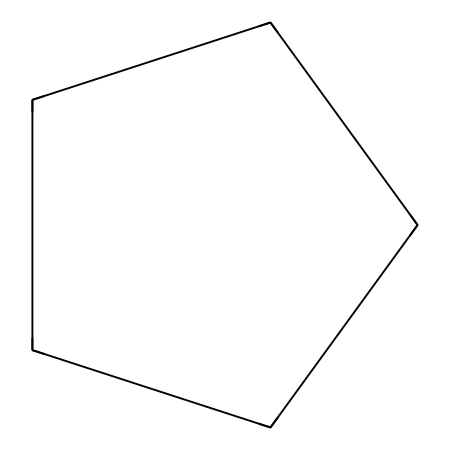What is the name of this chemical? The SMILES representation "C1CCCC1" corresponds to a cycloalkane. Specifically, it indicates a cyclic structure with five carbon atoms, which is known as cyclopentane.
Answer: cyclopentane How many carbon atoms are in cyclopentane? By analyzing the SMILES "C1CCCC1", we can see that there is a total of five 'C' symbols, indicating five carbon atoms within the structure.
Answer: five How many hydrogen atoms does cyclopentane have? Cyclopentane has the formula C5H10. Each carbon forms two hydrogens in a ring structure, resulting in 10 hydrogen atoms total.
Answer: ten Is cyclopentane a saturated or unsaturated hydrocarbon? The presence of only single bonds in cyclopentane, indicated by the absence of multiple bonds in the structure, confirms it is a saturated hydrocarbon.
Answer: saturated What type of ring structure does cyclopentane have? Cyclopentane is classified as a cycloalkane, which is characterized by its aliphatic ring structure containing carbon atoms.
Answer: aliphatic What is the bond angle in cyclopentane? The ideal bond angle in a cyclopentane structure is approximately 108 degrees, typical for sp3 hybridized carbon atoms in a cyclic configuration.
Answer: 108 degrees Does cyclopentane exhibit geometric isomerism? Due to the absence of double bonds in cyclopentane, there are no geometric isomers as this type of isomerism requires a different arrangement of substituents around double bonds.
Answer: no 